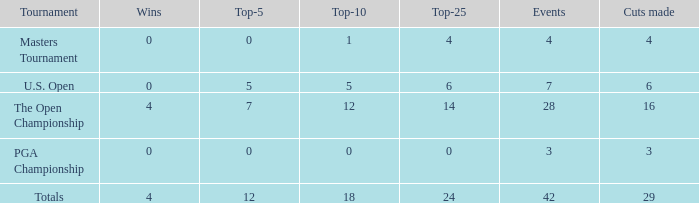What is the smallest for top-25 with happenings fewer than 42 in a u.s. open with a top-10 smaller than 5? None. 